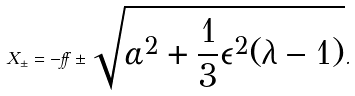Convert formula to latex. <formula><loc_0><loc_0><loc_500><loc_500>X _ { \pm } = - \alpha \pm \sqrt { \alpha ^ { 2 } + \frac { 1 } { 3 } \epsilon ^ { 2 } ( \lambda - 1 ) } .</formula> 